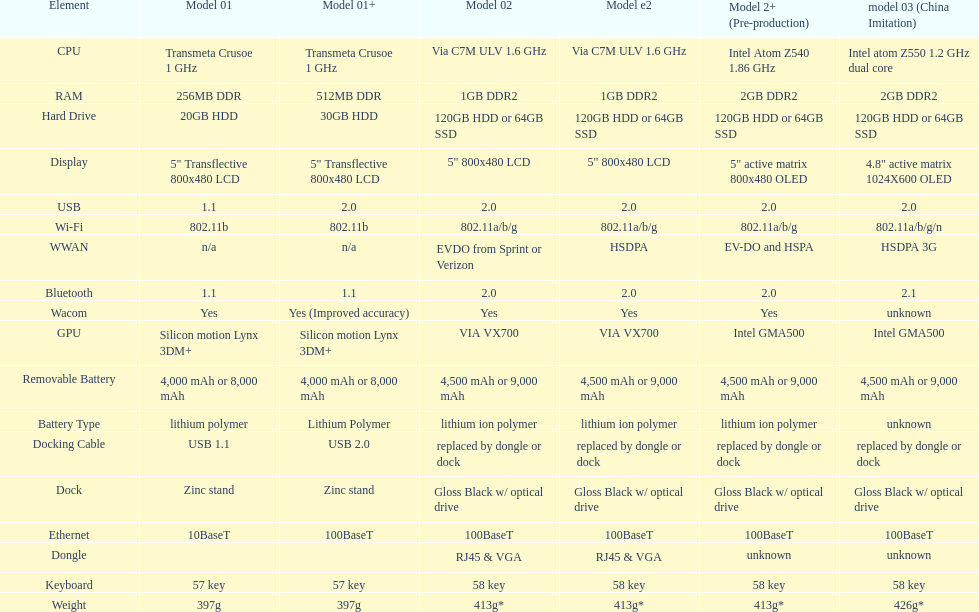Which model provides a larger hard drive: model 01 or model 02? Model 02. Help me parse the entirety of this table. {'header': ['Element', 'Model 01', 'Model 01+', 'Model 02', 'Model e2', 'Model 2+ (Pre-production)', 'model 03 (China Imitation)'], 'rows': [['CPU', 'Transmeta Crusoe 1\xa0GHz', 'Transmeta Crusoe 1\xa0GHz', 'Via C7M ULV 1.6\xa0GHz', 'Via C7M ULV 1.6\xa0GHz', 'Intel Atom Z540 1.86\xa0GHz', 'Intel atom Z550 1.2\xa0GHz dual core'], ['RAM', '256MB DDR', '512MB DDR', '1GB DDR2', '1GB DDR2', '2GB DDR2', '2GB DDR2'], ['Hard Drive', '20GB HDD', '30GB HDD', '120GB HDD or 64GB SSD', '120GB HDD or 64GB SSD', '120GB HDD or 64GB SSD', '120GB HDD or 64GB SSD'], ['Display', '5" Transflective 800x480 LCD', '5" Transflective 800x480 LCD', '5" 800x480 LCD', '5" 800x480 LCD', '5" active matrix 800x480 OLED', '4.8" active matrix 1024X600 OLED'], ['USB', '1.1', '2.0', '2.0', '2.0', '2.0', '2.0'], ['Wi-Fi', '802.11b', '802.11b', '802.11a/b/g', '802.11a/b/g', '802.11a/b/g', '802.11a/b/g/n'], ['WWAN', 'n/a', 'n/a', 'EVDO from Sprint or Verizon', 'HSDPA', 'EV-DO and HSPA', 'HSDPA 3G'], ['Bluetooth', '1.1', '1.1', '2.0', '2.0', '2.0', '2.1'], ['Wacom', 'Yes', 'Yes (Improved accuracy)', 'Yes', 'Yes', 'Yes', 'unknown'], ['GPU', 'Silicon motion Lynx 3DM+', 'Silicon motion Lynx 3DM+', 'VIA VX700', 'VIA VX700', 'Intel GMA500', 'Intel GMA500'], ['Removable Battery', '4,000 mAh or 8,000 mAh', '4,000 mAh or 8,000 mAh', '4,500 mAh or 9,000 mAh', '4,500 mAh or 9,000 mAh', '4,500 mAh or 9,000 mAh', '4,500 mAh or 9,000 mAh'], ['Battery Type', 'lithium polymer', 'Lithium Polymer', 'lithium ion polymer', 'lithium ion polymer', 'lithium ion polymer', 'unknown'], ['Docking Cable', 'USB 1.1', 'USB 2.0', 'replaced by dongle or dock', 'replaced by dongle or dock', 'replaced by dongle or dock', 'replaced by dongle or dock'], ['Dock', 'Zinc stand', 'Zinc stand', 'Gloss Black w/ optical drive', 'Gloss Black w/ optical drive', 'Gloss Black w/ optical drive', 'Gloss Black w/ optical drive'], ['Ethernet', '10BaseT', '100BaseT', '100BaseT', '100BaseT', '100BaseT', '100BaseT'], ['Dongle', '', '', 'RJ45 & VGA', 'RJ45 & VGA', 'unknown', 'unknown'], ['Keyboard', '57 key', '57 key', '58 key', '58 key', '58 key', '58 key'], ['Weight', '397g', '397g', '413g*', '413g*', '413g*', '426g*']]} 